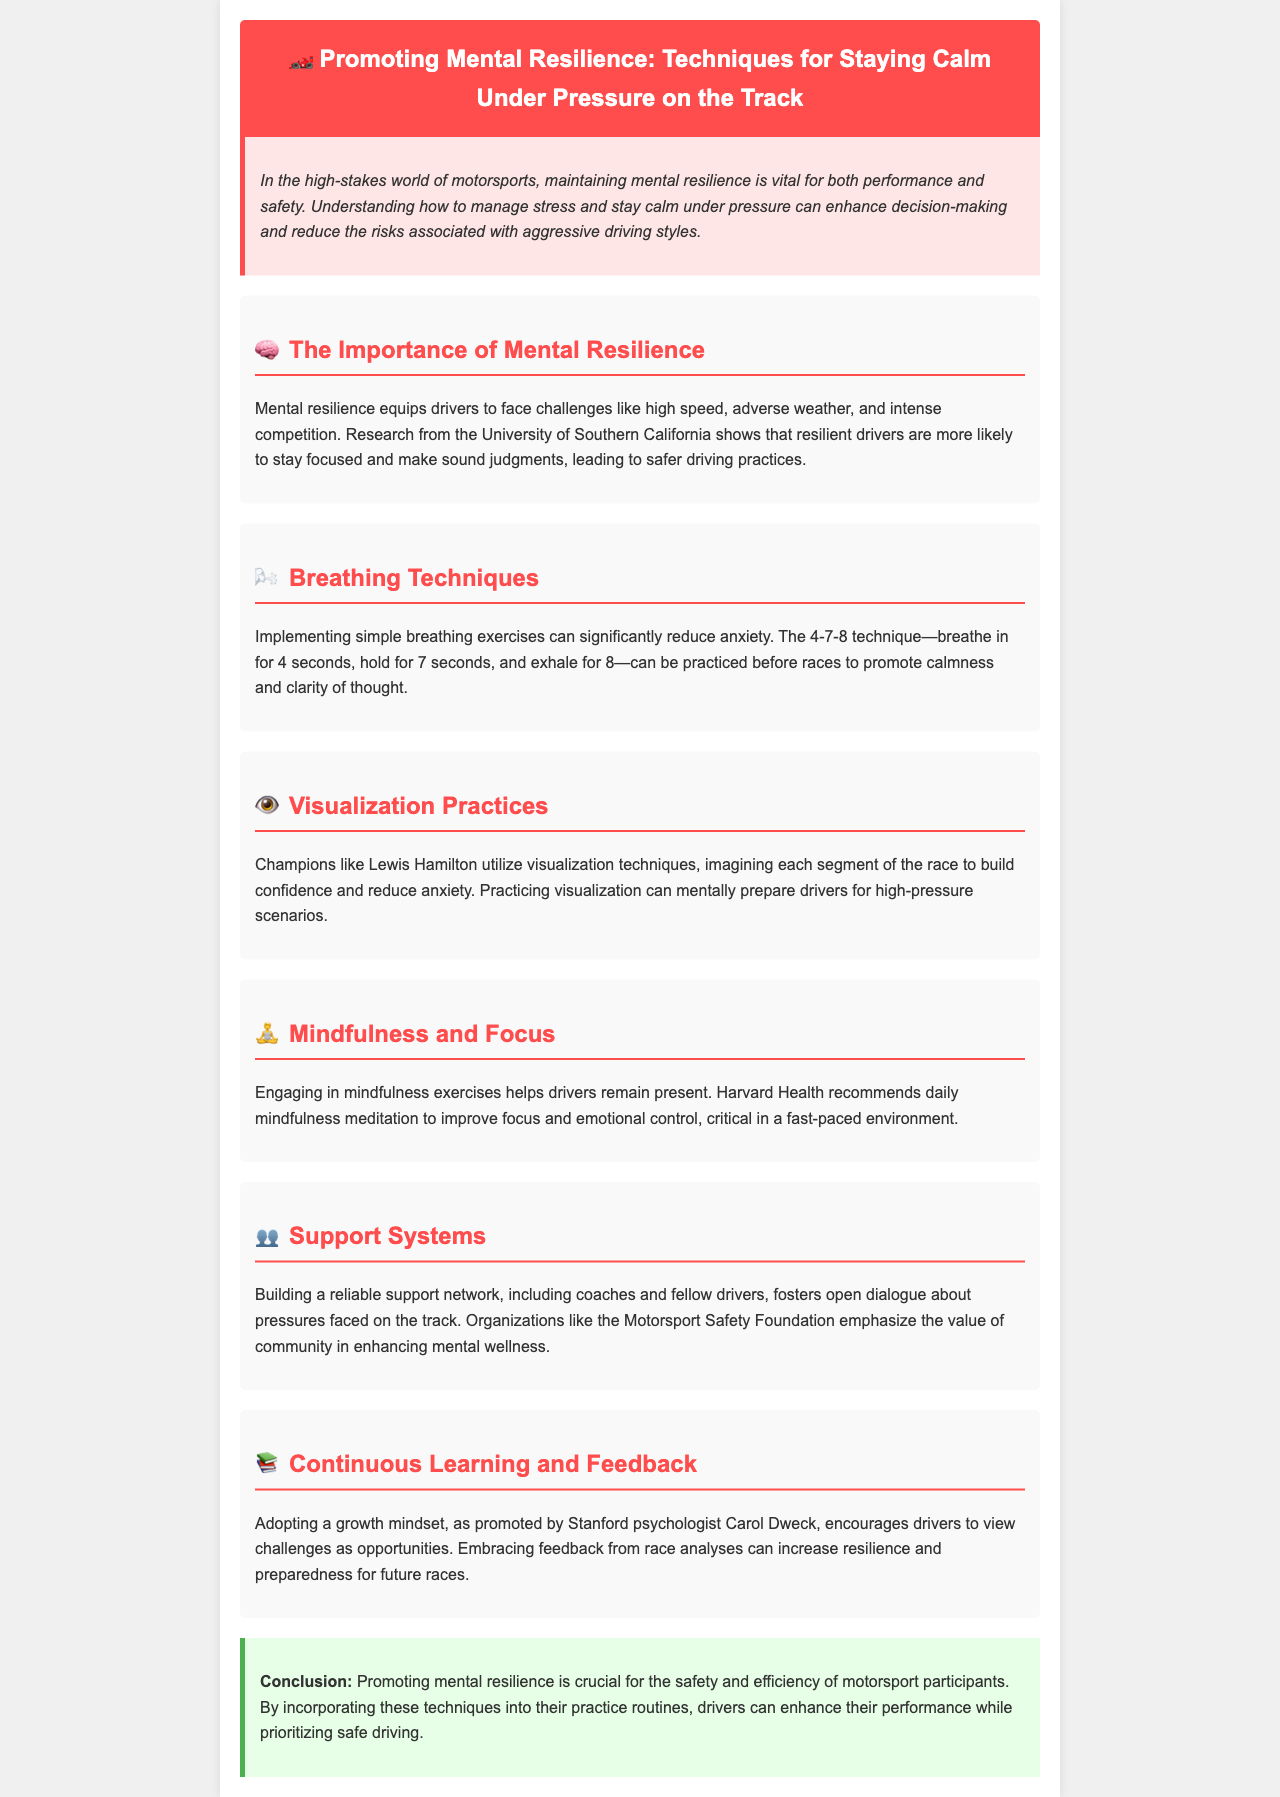What is the main focus of the brochure? The main focus of the brochure is the importance of maintaining mental resilience in motorsports to improve performance and safety.
Answer: Mental resilience What breathing technique is mentioned in the document? The brochure describes the 4-7-8 breathing technique as a method to promote calmness.
Answer: 4-7-8 technique Who is cited as an example of using visualization techniques? The brochure mentions Lewis Hamilton as a champion who utilizes visualization practices to build confidence.
Answer: Lewis Hamilton What organization emphasizes the value of community in enhancing mental wellness? The Motorsport Safety Foundation is highlighted in the brochure as promoting community support for mental wellness in motorsports.
Answer: Motorsport Safety Foundation What mindset does Carol Dweck promote for drivers? Carol Dweck promotes a growth mindset, encouraging drivers to view challenges as opportunities for growth.
Answer: Growth mindset What is a recommended daily practice for improving focus, according to the brochure? The brochure recommends daily mindfulness meditation to help improve focus and emotional control.
Answer: Mindfulness meditation How does mental resilience affect decision-making according to the University of Southern California? Research shows that resilient drivers are more likely to stay focused and make sound judgments, leading to safer driving practices.
Answer: Safe driving practices What do breathing techniques help to reduce? Breathing techniques are implemented to significantly reduce anxiety for drivers.
Answer: Anxiety 